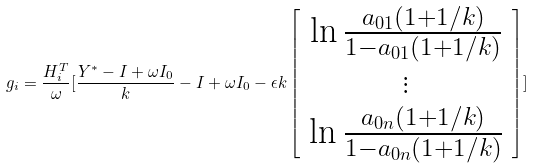Convert formula to latex. <formula><loc_0><loc_0><loc_500><loc_500>g _ { i } = \frac { H _ { i } ^ { T } } { \omega } [ \frac { Y ^ { * } - I + \omega I _ { 0 } } { k } - I + \omega I _ { 0 } - \epsilon k \left [ \begin{array} { c } \ln \frac { a _ { 0 1 } ( 1 + 1 / k ) } { 1 - a _ { 0 1 } ( 1 + 1 / k ) } \\ \vdots \\ \ln \frac { a _ { 0 n } ( 1 + 1 / k ) } { 1 - a _ { 0 n } ( 1 + 1 / k ) } \end{array} \right ] ]</formula> 